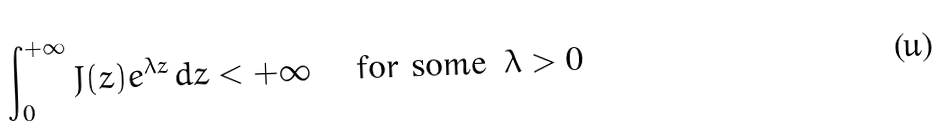Convert formula to latex. <formula><loc_0><loc_0><loc_500><loc_500>\int _ { 0 } ^ { + \infty } J ( z ) e ^ { \lambda z } \, d z < + \infty \quad \text { for some } \, \lambda > 0</formula> 